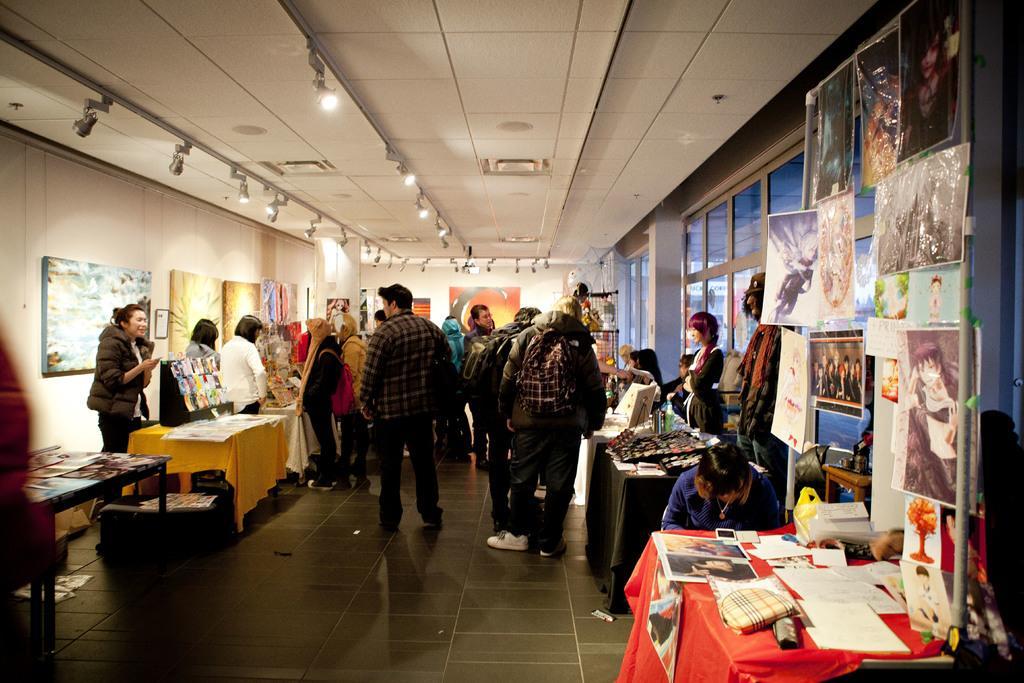Could you give a brief overview of what you see in this image? There are some people standing in this room. Some of them were standing in front of a tables. There are some photographs attached to the windows here. In the background there is a wall and some lights. 